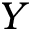Convert formula to latex. <formula><loc_0><loc_0><loc_500><loc_500>Y</formula> 